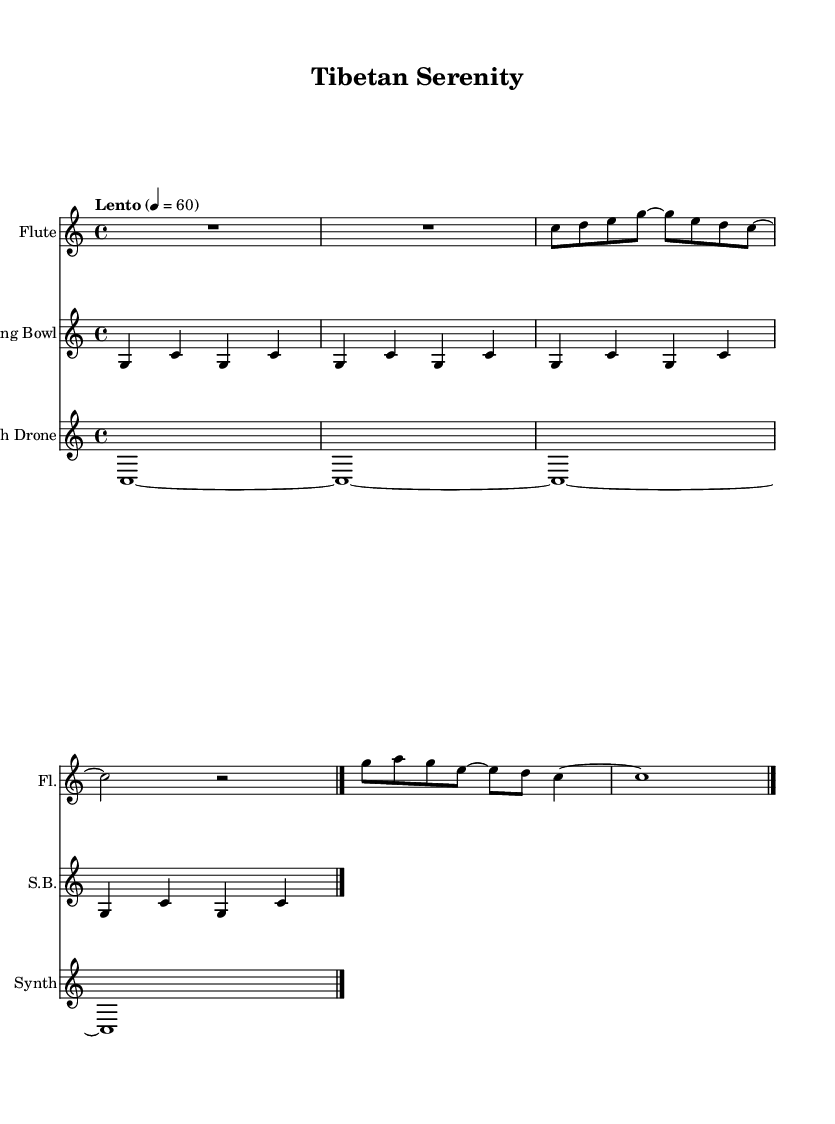What is the key signature of this music? The key signature is indicated by the absence of sharps or flats in the music, which signifies that it is in C major.
Answer: C major What is the time signature of this piece? The time signature appears at the beginning of the music and is represented as 4/4, meaning there are four beats in a measure and the quarter note receives one beat.
Answer: 4/4 What is the tempo marking for this composition? The tempo marking is indicated in Italian, stating "Lento," which means slow, and it is set at a metronome marking of 60 beats per minute.
Answer: Lento 60 How many measures are present in the flute part? The flute part has a specific number of measures outlined in the music. By counting the segments divided by bar lines, it shows there are four measures in total.
Answer: 4 What instrument is indicated to perform the drone part? The instrument performing the drone part is labeled in the sheet music as "Synth Drone," which can be seen in the staff designation.
Answer: Synth Drone Identify the repeating pattern in the singing bowl part. The singing bowl part consists of a repeating pattern of four notes: G and C, which is repeated throughout the segment, showing the tranquility and continuity typical in meditative music.
Answer: G and C What is the dynamic indication for the flute part? The dynamic marking for the flute part is indicated as "Up," which corresponds to the way the dynamics are interpreted for this instrument, suggesting an expressive or loud articulation.
Answer: Up 